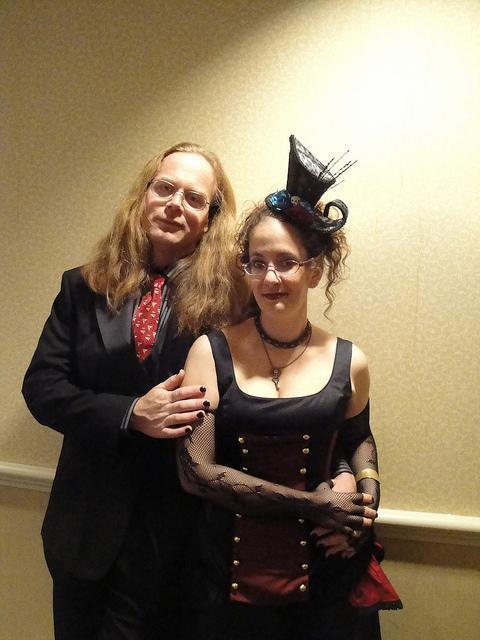How many people are in the photo?
Give a very brief answer. 2. 